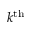<formula> <loc_0><loc_0><loc_500><loc_500>k ^ { t h }</formula> 